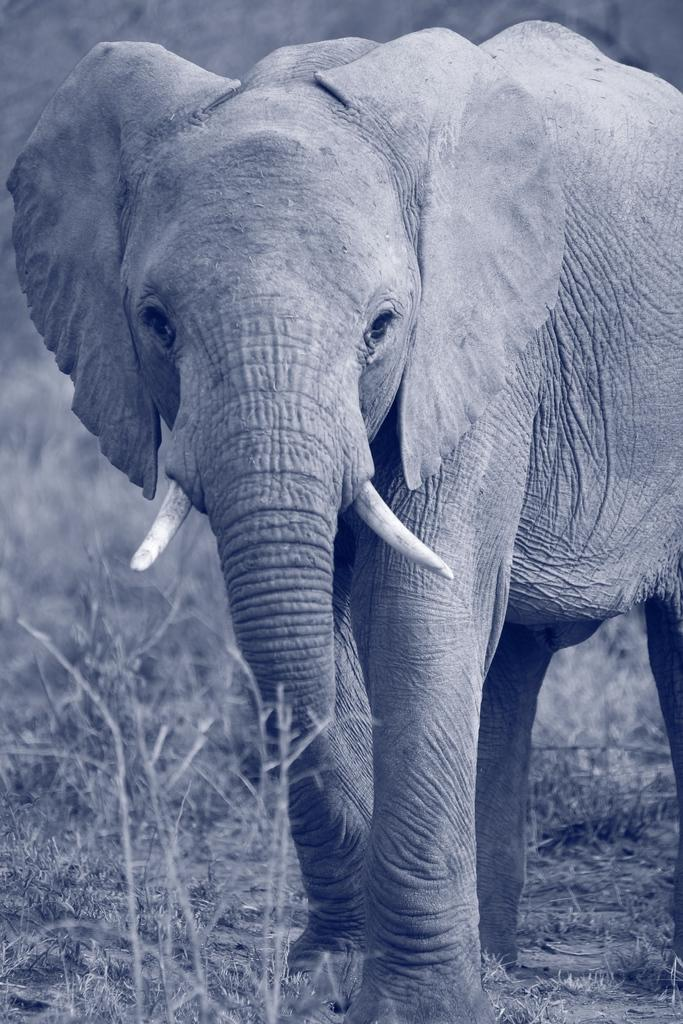What is the color scheme of the image? The image is black and white. What animal can be seen in the image? There is an elephant in the image. What type of terrain is the elephant standing on? The elephant is on grassy land. What type of thought can be seen in the image? There are no thoughts visible in the image, as thoughts are not tangible objects that can be seen. 